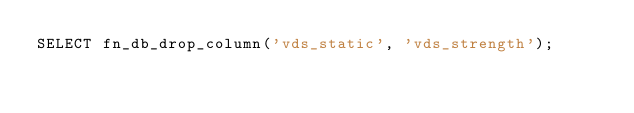<code> <loc_0><loc_0><loc_500><loc_500><_SQL_>SELECT fn_db_drop_column('vds_static', 'vds_strength');
</code> 